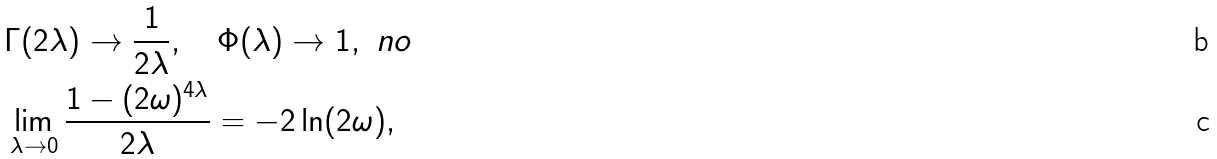Convert formula to latex. <formula><loc_0><loc_0><loc_500><loc_500>& \Gamma ( 2 \lambda ) \to \frac { 1 } { 2 \lambda } , \quad \Phi ( \lambda ) \to 1 , \ n o \\ & \lim _ { \lambda \to 0 } \frac { 1 - ( 2 \omega ) ^ { 4 \lambda } } { 2 \lambda } = - 2 \ln ( 2 \omega ) ,</formula> 